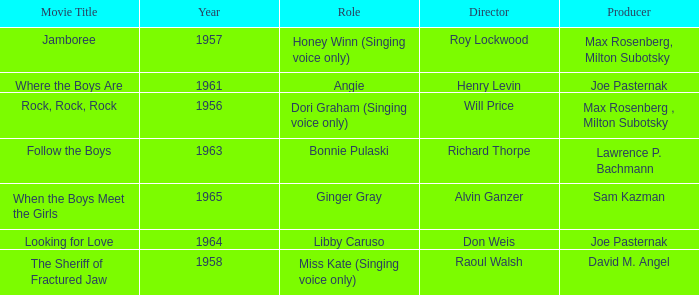What were the roles in 1961? Angie. 